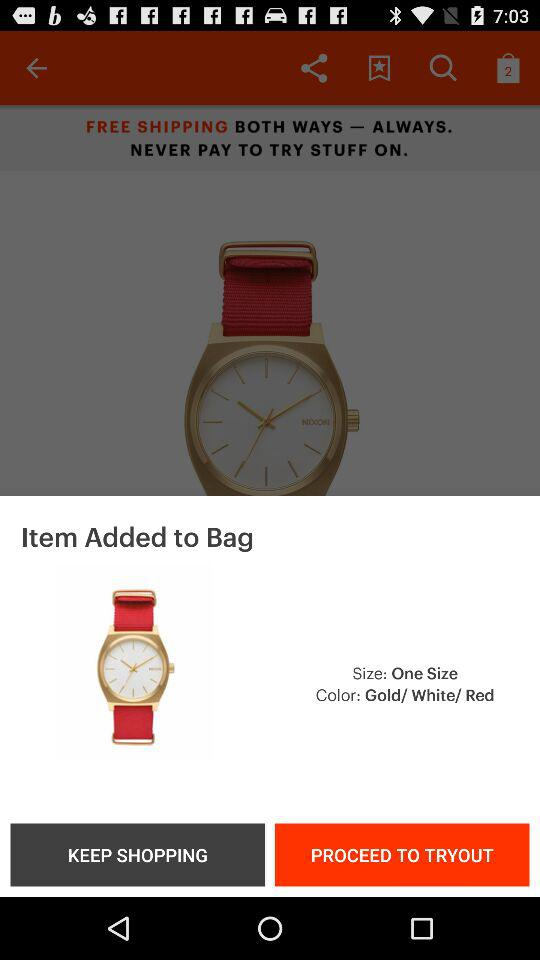What are the mentioned colors? The mentioned colors are gold, white and red. 